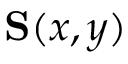<formula> <loc_0><loc_0><loc_500><loc_500>S ( x , y )</formula> 